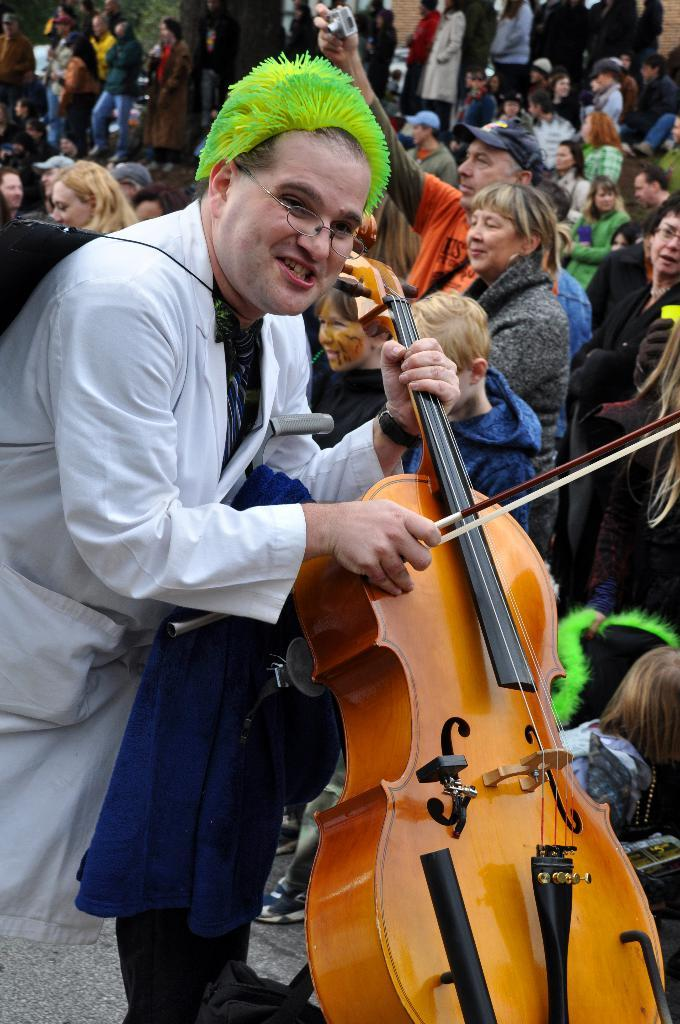Where was the image taken? The image is taken outdoors. Who is present in the image? There is a man in the image. What is the man wearing? The man is wearing a white shirt. What is the man holding in the image? The man is holding a violin. Can you describe the people in the background of the image? There is a group of people in the background of the image, and they are standing on the floor. Is there any snow visible in the image? No, there is no snow present in the image. How many chairs are visible in the image? There are no chairs visible in the image. 